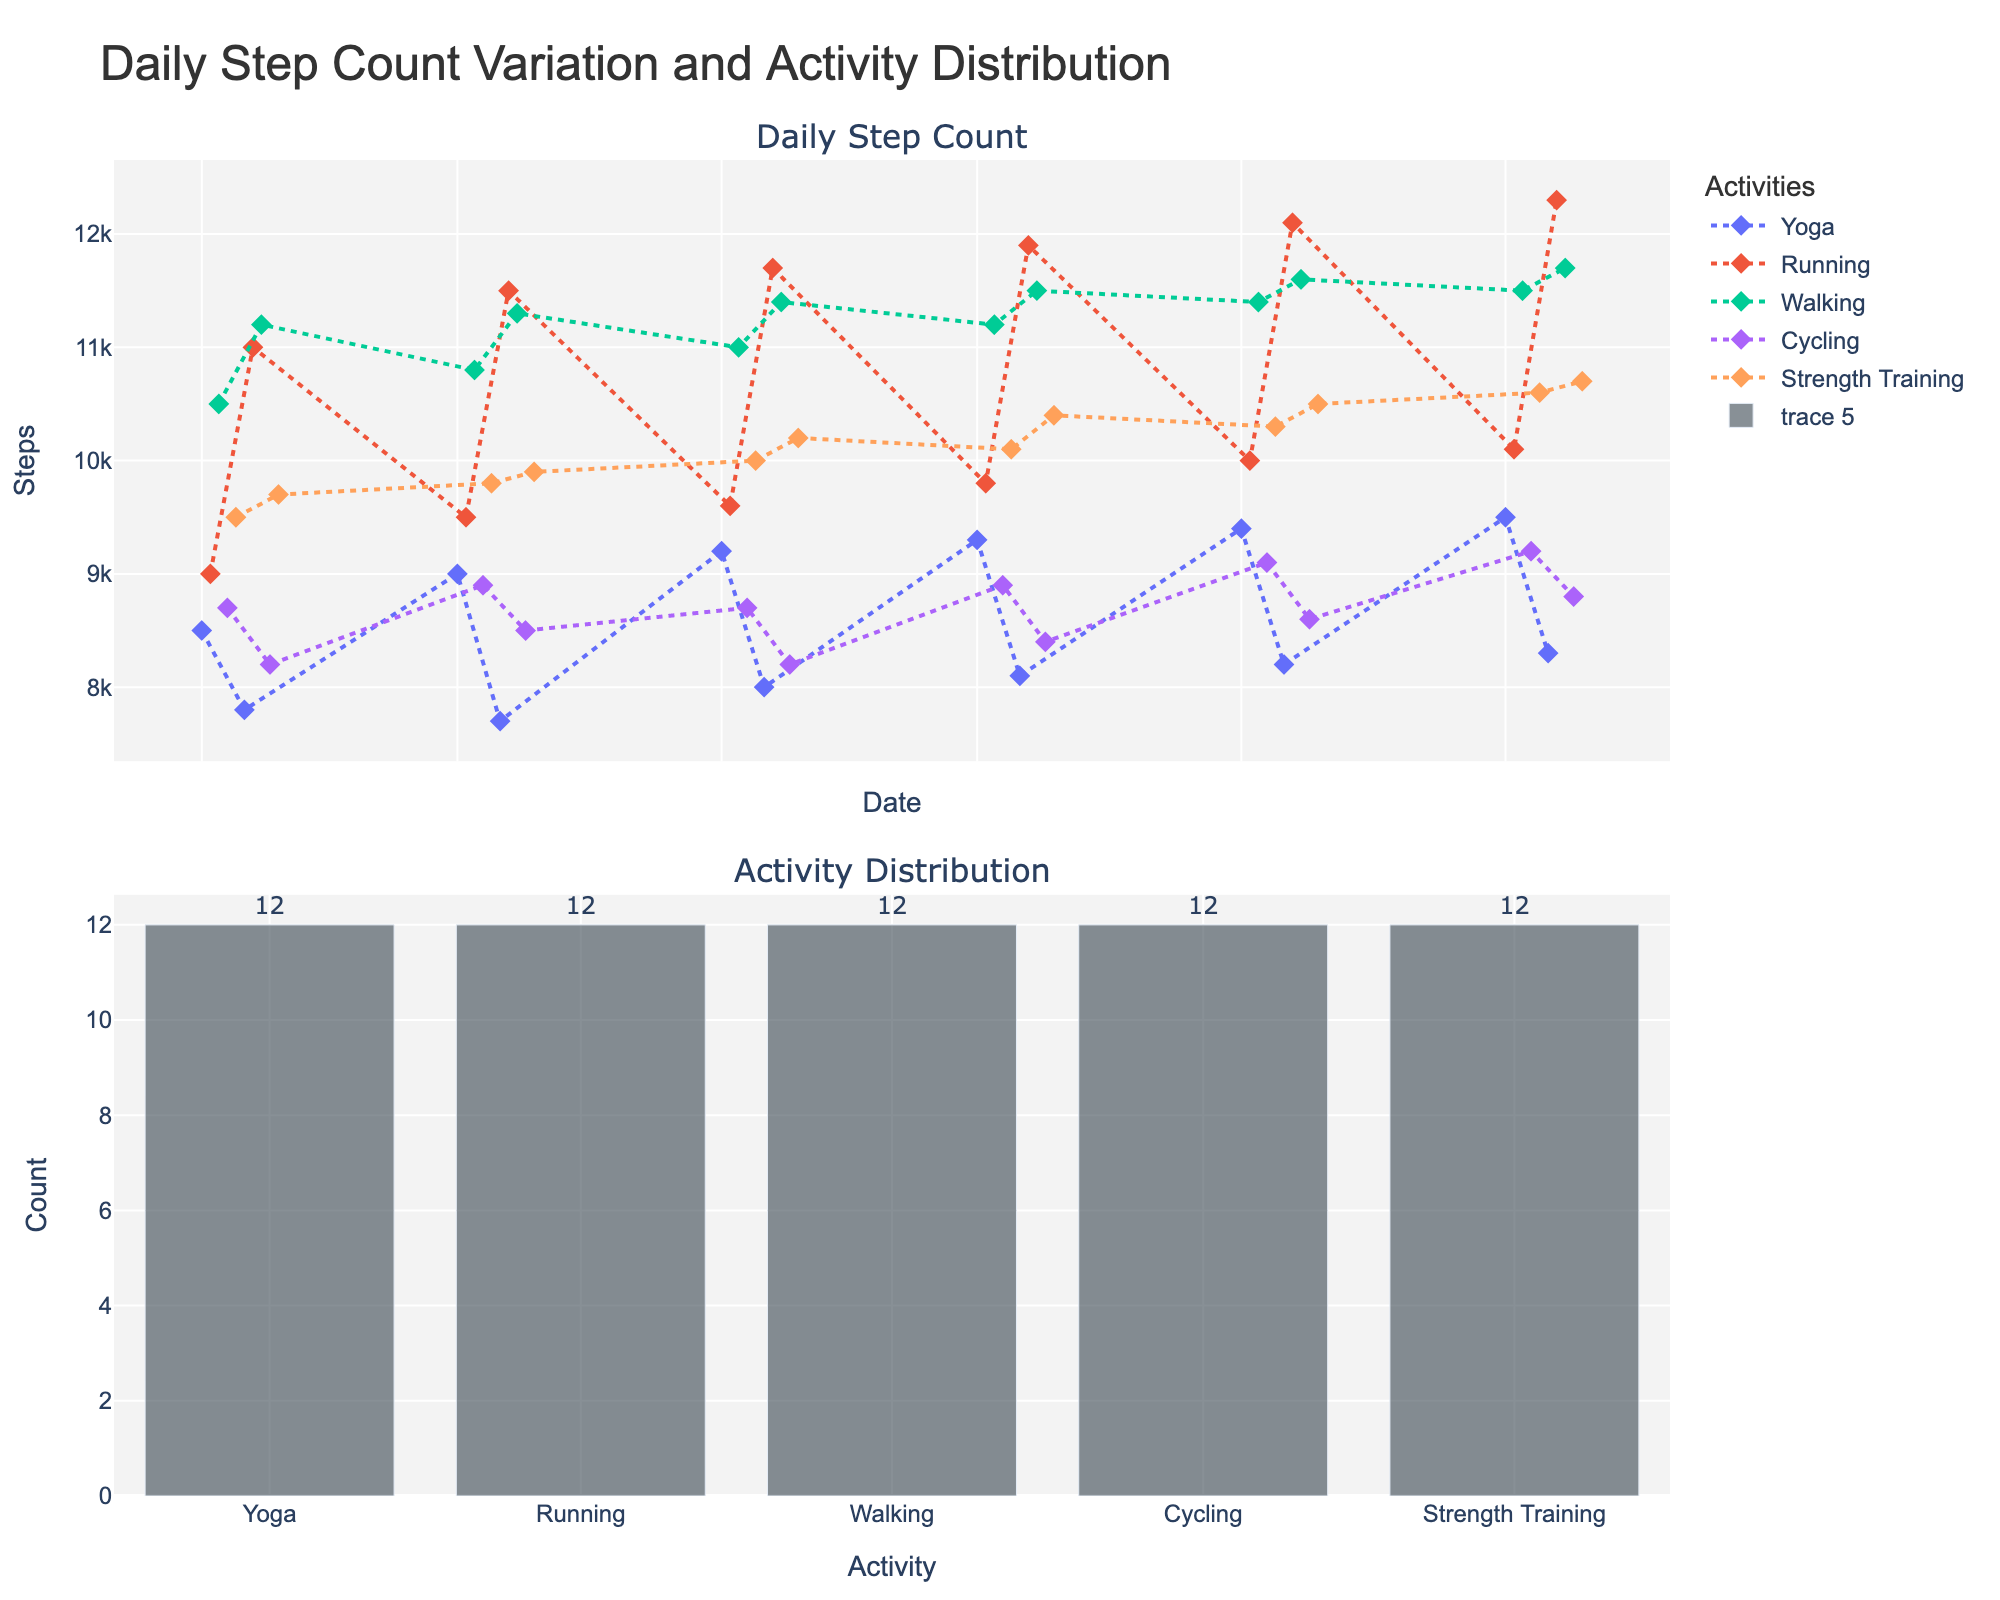What is the title of the figure? The title is usually large and located at the top center of the figure. In this case, the title reads "Daily Step Count Variation and Activity Distribution".
Answer: Daily Step Count Variation and Activity Distribution How many unique activities are plotted in the figure? Look at the legend on the first subplot where different colors and markers represent each unique activity. The activities listed are Yoga, Running, Walking, Cycling, and Strength Training.
Answer: 5 Which day had the highest step count and what was the activity on that day? By examining the peaks in the first subplot for daily step count, you can see that the highest step count is on 2023-09-07 with 12,300 steps. The legend indicates that Running is the activity.
Answer: 2023-09-07, Running How many days have data for the Yoga activity? Check the bar chart in the second subplot. The count for Yoga is 10 days.
Answer: 10 Which activity has the highest count? Refer to the bar chart in the second subplot. Running has the highest count with 10 entries.
Answer: Running Which activity tends to have the highest average daily step count? Observe the scatter plot in the first subplot; calculate the average step count per activity. Running consistently shows higher values in comparison to other activities.
Answer: Running Compare the step counts of Yoga and Running on 2023-09-01 and 2023-09-02, respectively. Which is higher? The figure shows a step count of 9,500 for Yoga on 2023-09-01 and 10,100 for Running on 2023-09-02. Running is higher.
Answer: Running On which dates did the Strength Training activity have step counts above 10,000? Look at the scatter plot for the Strength Training category and identify the dates where the step count exceeds 10,000. The dates are 2023-06-10, 2023-07-10, 2023-08-10, and 2023-09-10.
Answer: 2023-06-10, 2023-07-10, 2023-08-10, 2023-09-10 Is there any month where the Yoga activity consistently shows steps below 8,500? Examine the scatter plot trend lines for Yoga over the months. In May, the step counts for Yoga on 2023-05-06 are below 8,500.
Answer: May 